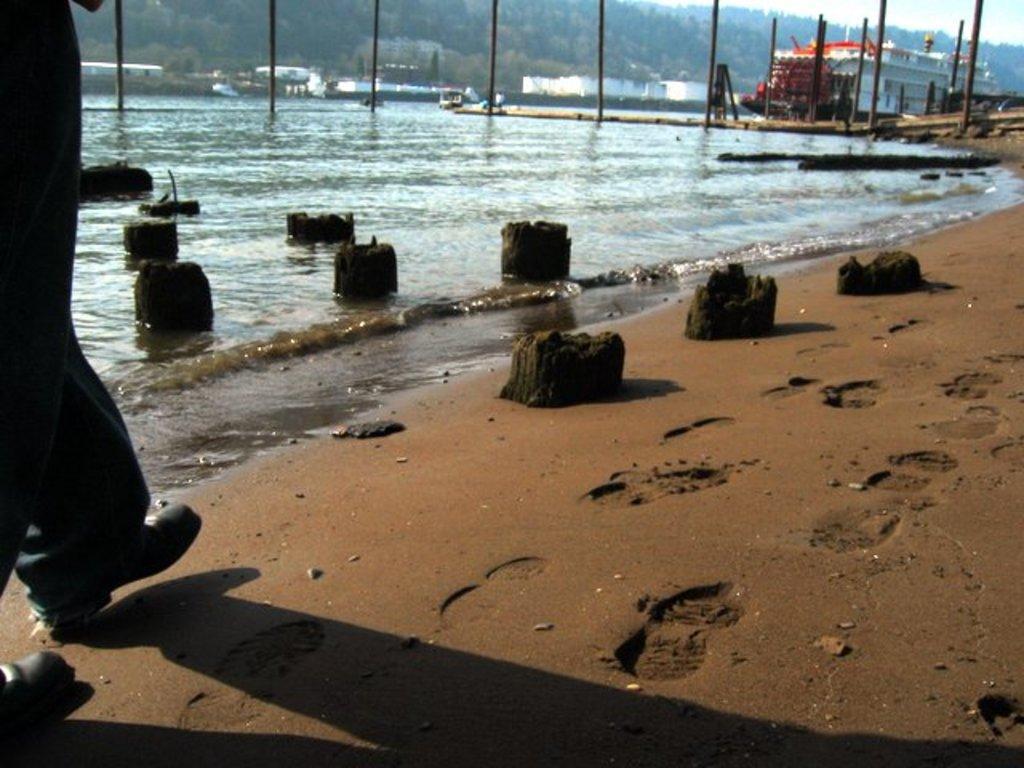In one or two sentences, can you explain what this image depicts? In this picture we can see sand, water, poles and objects. On the left side of the image we can see person's legs. In the background of the image we can see ship, boat, people, houses, trees and sky. 